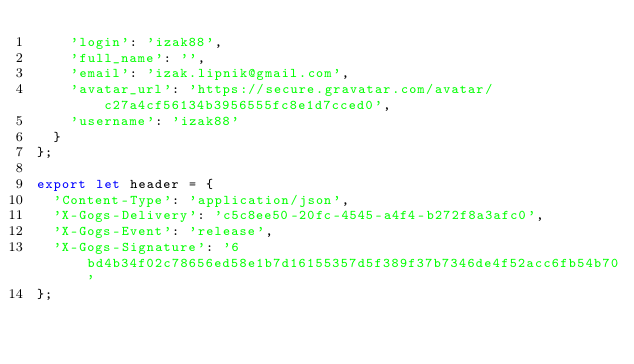Convert code to text. <code><loc_0><loc_0><loc_500><loc_500><_TypeScript_>    'login': 'izak88',
    'full_name': '',
    'email': 'izak.lipnik@gmail.com',
    'avatar_url': 'https://secure.gravatar.com/avatar/c27a4cf56134b3956555fc8e1d7cced0',
    'username': 'izak88'
  }
};

export let header = {
  'Content-Type': 'application/json',
  'X-Gogs-Delivery': 'c5c8ee50-20fc-4545-a4f4-b272f8a3afc0',
  'X-Gogs-Event': 'release',
  'X-Gogs-Signature': '6bd4b34f02c78656ed58e1b7d16155357d5f389f37b7346de4f52acc6fb54b70'
};
</code> 